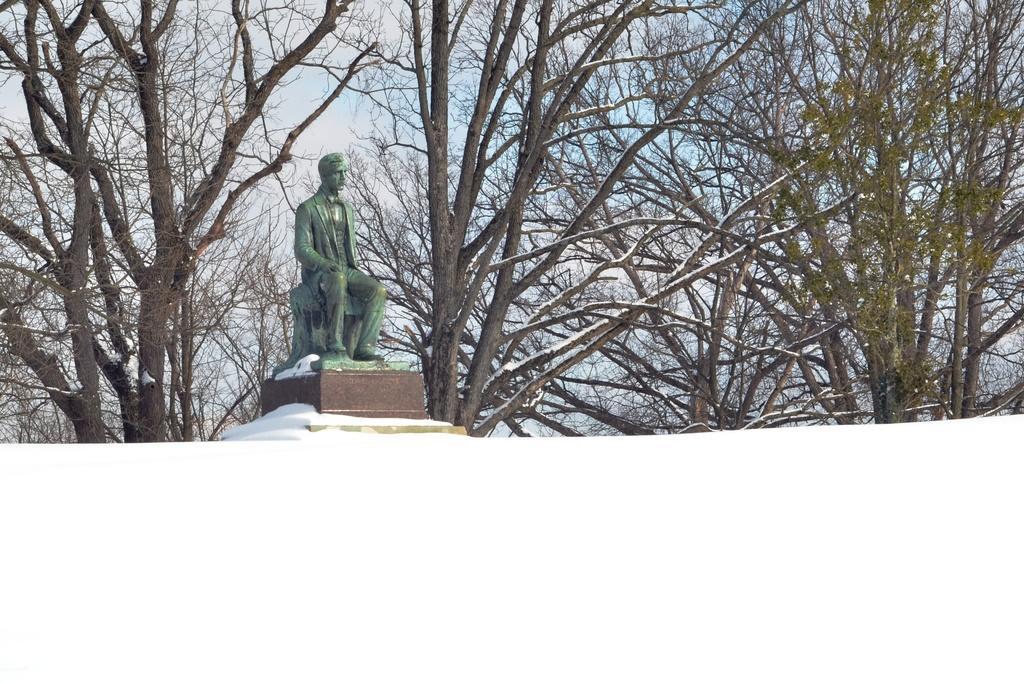Can you describe this image briefly? In the center of the image there is a statue. In the background of the image there are trees and sky. 